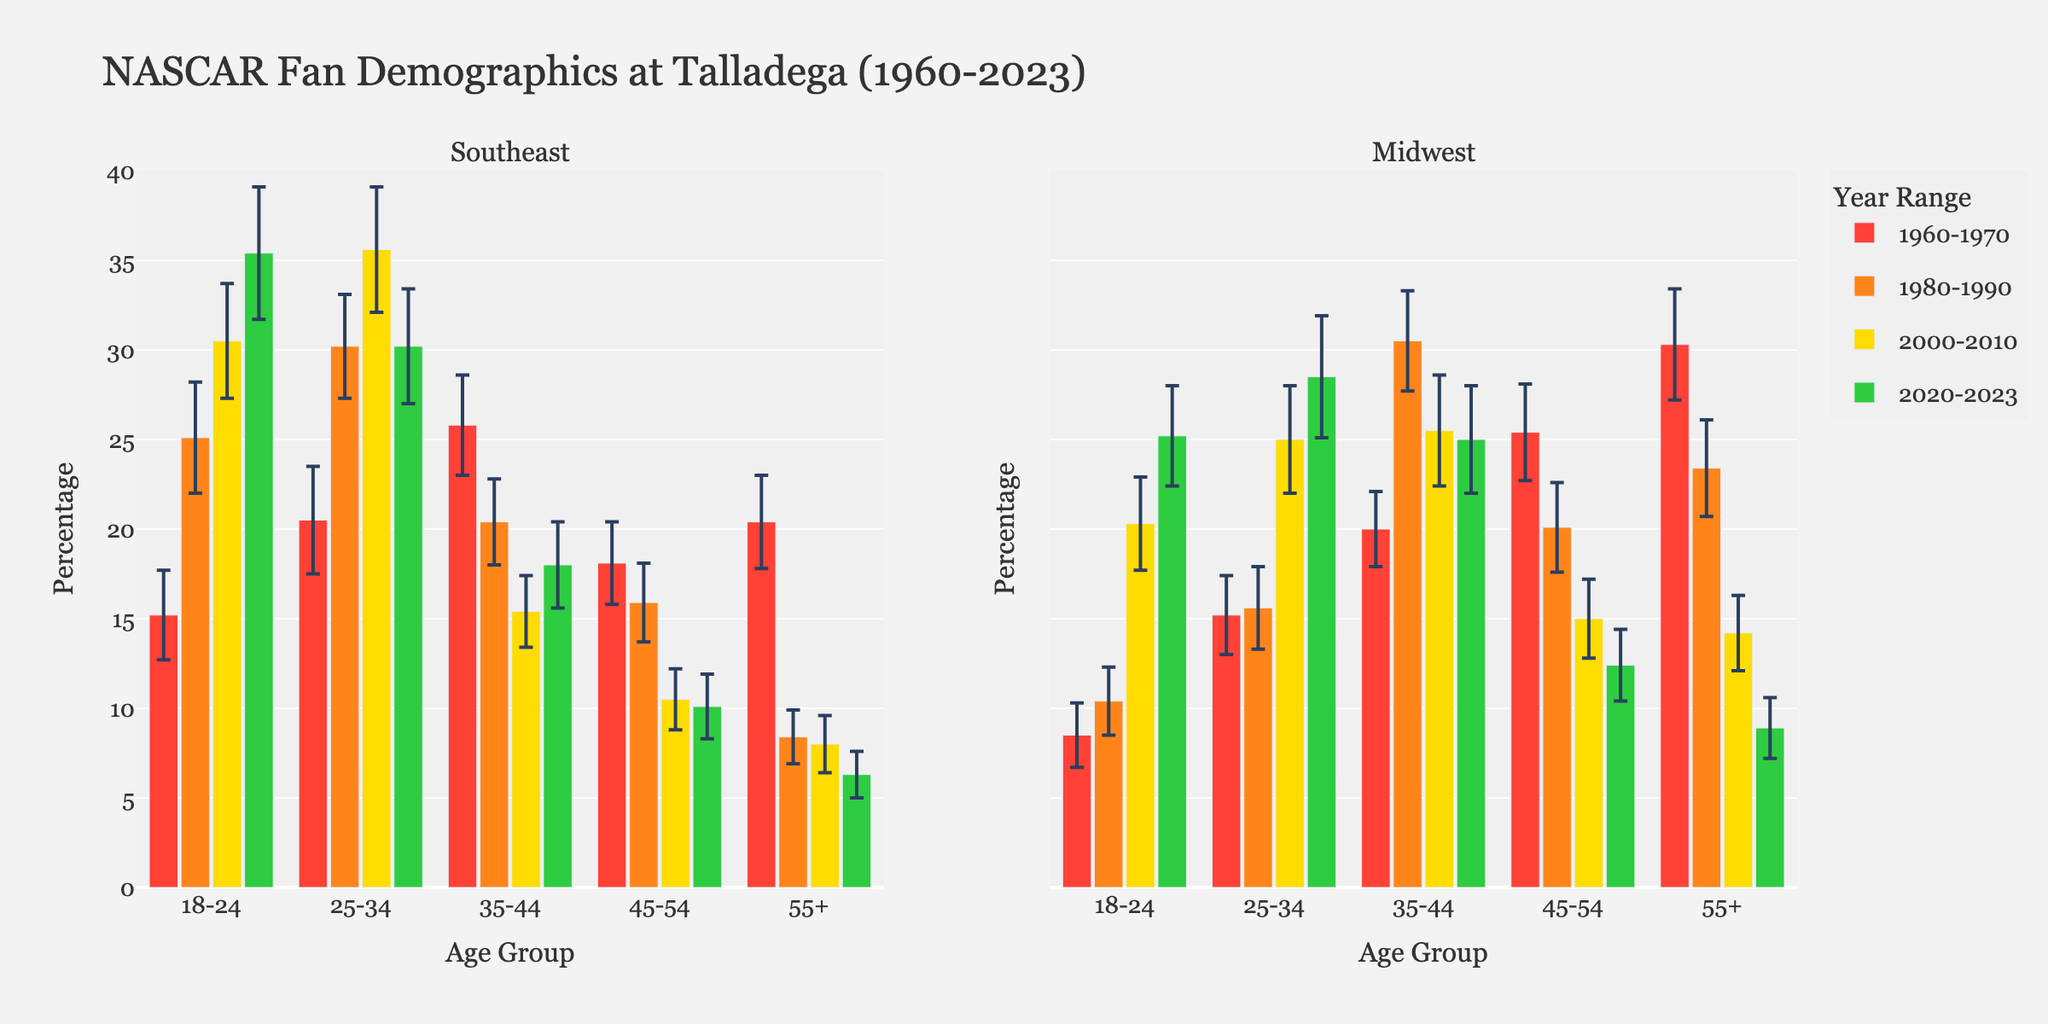What is the title of the figure? The title is typically found at the top of the figure and provides a summary of what the figure depicts.
Answer: NASCAR Fan Demographics at Talladega (1960-2023) What are the two regions compared in the subplots? The subplot titles indicate the regions being compared. The titles are displayed above each subplot.
Answer: Southeast and Midwest Which age group in the Southeast had the highest percentage of fans in 2020-2023? Look at the 2020-2023 group within the Southeast subplot and identify the highest bar.
Answer: 18-24 How does the percentage of 18-24 year-old fans in the Midwest compare between 1960-1970 and 2020-2023? Compare the heights of the bars for the 18-24 age group in the Midwest subplot for the years 1960-1970 and 2020-2023.
Answer: Higher in 2020-2023 In which region and age group did the percentage of fans decrease the most from 1960-1970 to 2020-2023? Identify the age group within each region and calculate the difference in percentage between 1960-1970 and 2020-2023, then compare across regions.
Answer: 55+ in the Southeast What is the trend in the percentage of 25-34 year-old fans in the Southeast from 1960-1970 to 2020-2023? Examine the bars for the 25-34 age group in the Southeast subplot across the different time periods.
Answer: Increasing How do the standard deviations for the 35-44 age group in the Midwest compare across the different time periods? Look at the error bars (representing standard deviation) for the 35-44 age group in the Midwest subplot across each time period and compare their lengths.
Answer: 2010-2023 > 2000-2010 ≈ 1980-1990 ≈ 1960-1970 Which age group had a more stable fan base in the Southeast from 1960-2023 based on standard deviation? Identify the age group with the smallest error bars in the Southeast subplot across all time periods.
Answer: 55+ Which region saw a greater increase in the percentage of 18-24 fans from 1960-1970 to 2020-2023? Compare the increase for the 18-24 age group between the two regions. Calculate the difference for each region and then compare the two differences. Southeast: 35.4 - 15.2 = 20.2; Midwest: 25.2 - 8.5 = 16.7
Answer: Southeast 